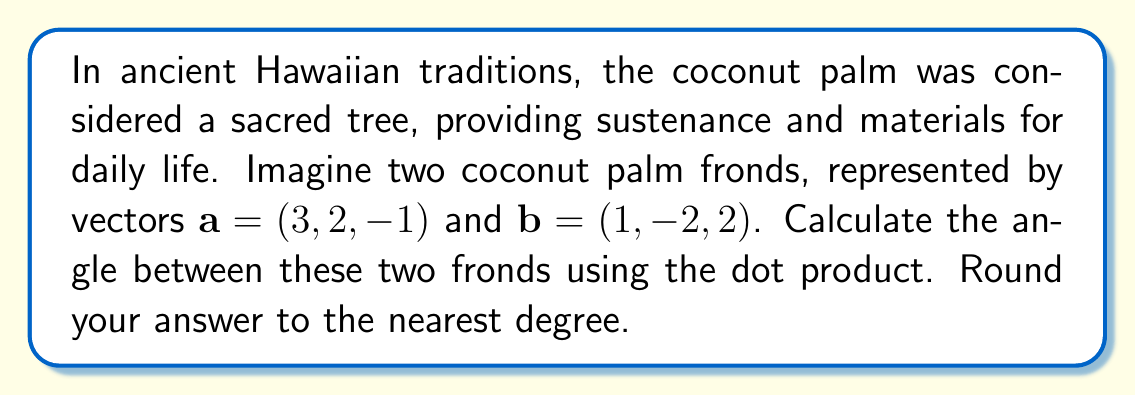Can you solve this math problem? To find the angle between two vectors using the dot product, we'll follow these steps:

1. Calculate the dot product of $\mathbf{a}$ and $\mathbf{b}$:
   $$\mathbf{a} \cdot \mathbf{b} = (3)(1) + (2)(-2) + (-1)(2) = 3 - 4 - 2 = -3$$

2. Calculate the magnitudes of $\mathbf{a}$ and $\mathbf{b}$:
   $$|\mathbf{a}| = \sqrt{3^2 + 2^2 + (-1)^2} = \sqrt{9 + 4 + 1} = \sqrt{14}$$
   $$|\mathbf{b}| = \sqrt{1^2 + (-2)^2 + 2^2} = \sqrt{1 + 4 + 4} = 3$$

3. Use the formula for the angle $\theta$ between two vectors:
   $$\cos \theta = \frac{\mathbf{a} \cdot \mathbf{b}}{|\mathbf{a}||\mathbf{b}|}$$

4. Substitute the values:
   $$\cos \theta = \frac{-3}{\sqrt{14} \cdot 3}$$

5. Solve for $\theta$ using the inverse cosine (arccos) function:
   $$\theta = \arccos\left(\frac{-3}{\sqrt{14} \cdot 3}\right)$$

6. Calculate the result and round to the nearest degree:
   $$\theta \approx 106.60^\circ \approx 107^\circ$$
Answer: The angle between the two coconut palm fronds is approximately 107°. 